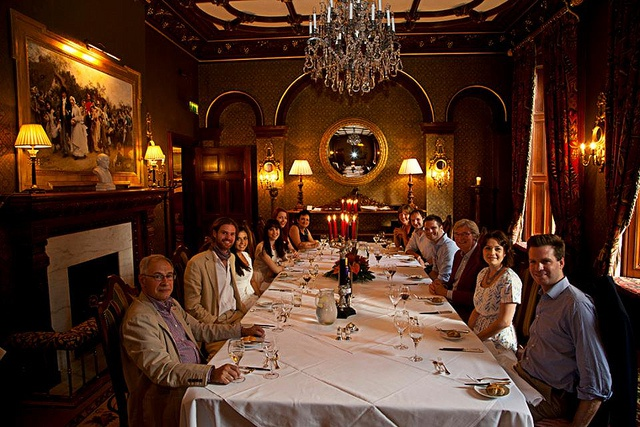Describe the objects in this image and their specific colors. I can see dining table in black, darkgray, and gray tones, people in black, maroon, and gray tones, people in black, maroon, gray, and darkgray tones, people in black, maroon, brown, and ivory tones, and people in black, maroon, and brown tones in this image. 